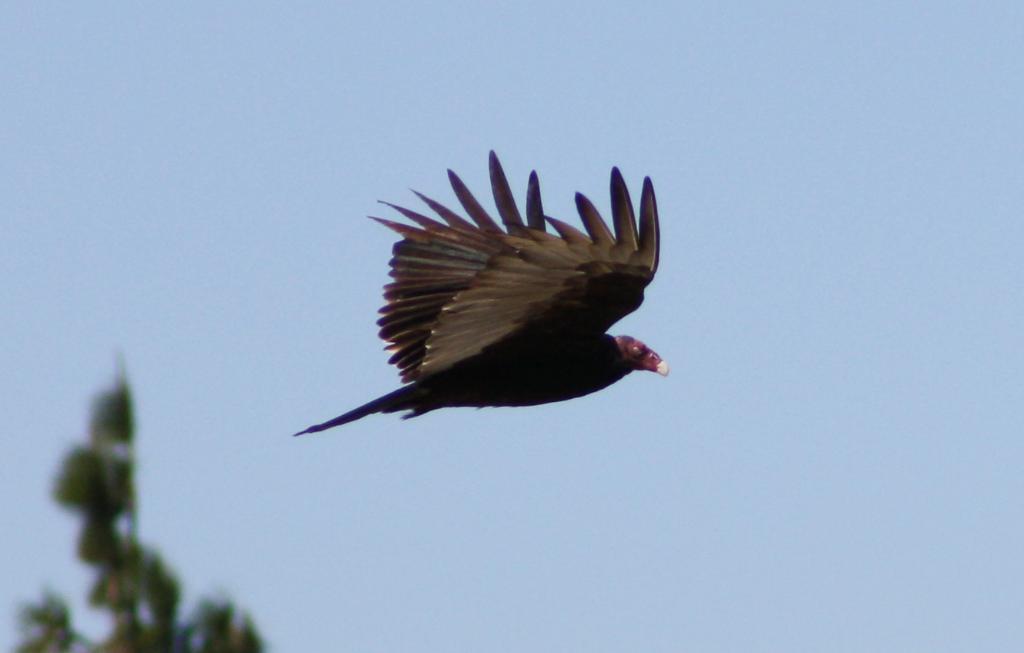In one or two sentences, can you explain what this image depicts? In the center of the picture we can see a bird flying. Towards left there is an object. The background is blurred. 